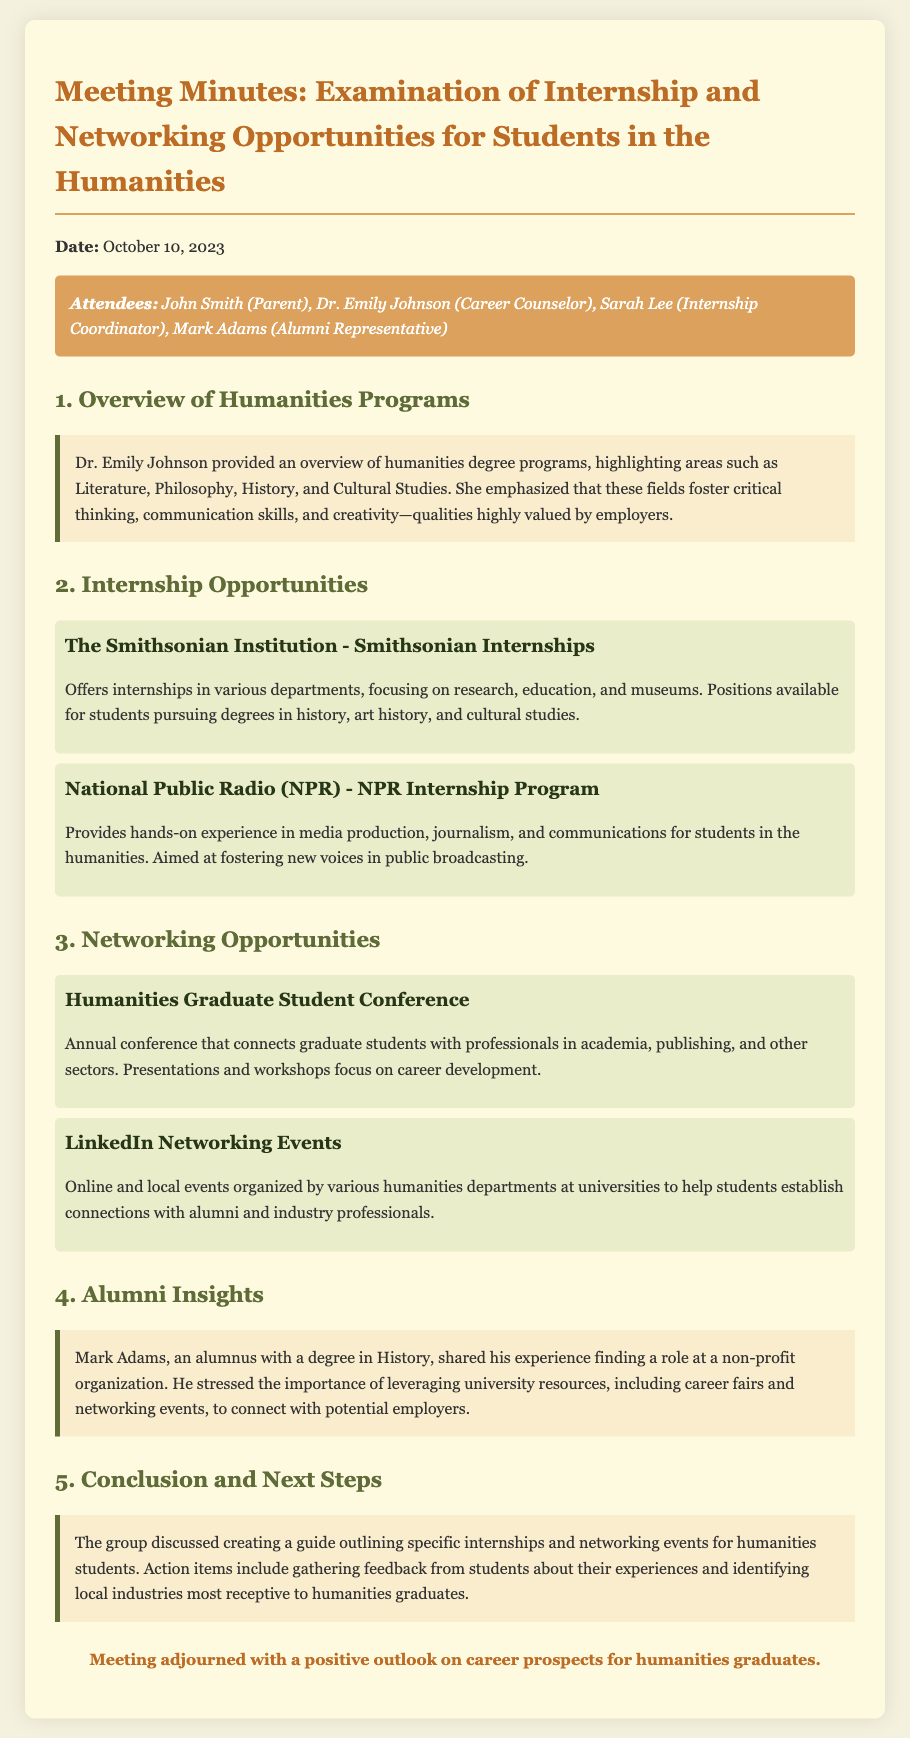What is the date of the meeting? The date of the meeting is mentioned at the beginning of the document.
Answer: October 10, 2023 Who provided an overview of humanities programs? The overview of humanities programs was provided by Dr. Emily Johnson.
Answer: Dr. Emily Johnson Which institution offers internships in history and art history? The document lists the Smithsonian Institution as offering internships in these fields.
Answer: Smithsonian Institution What type of experience does the NPR Internship Program provide? The NPR Internship Program provides experience in media production, journalism, and communications.
Answer: Media production, journalism, and communications What annual event connects graduate students with professionals? The Humanities Graduate Student Conference is an annual event for this purpose.
Answer: Humanities Graduate Student Conference How did Mark Adams find his role? Mark Adams found his role by leveraging university resources, including career fairs and networking events.
Answer: Leveraging university resources What action items were discussed for humanities students? The group discussed gathering feedback from students and identifying local industries.
Answer: Gathering feedback and identifying local industries What is the overall outlook on career prospects for humanities graduates? The conclusion notes a positive outlook on career prospects.
Answer: Positive outlook 